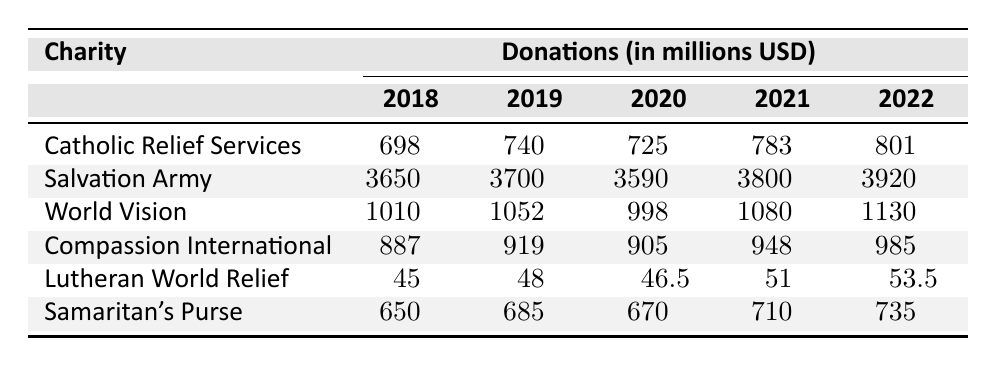What was the highest donation received in 2022? In 2022, the highest donation appears in the row for the Salvation Army with 3920 million USD.
Answer: 3920 million USD Which charity received the least donations in 2020? By looking at the donations for 2020, Lutheran World Relief received the least with 46.5 million USD.
Answer: 46.5 million USD What is the total amount of donations received by Compassion International from 2018 to 2022? Adding the donations from 2018 to 2022 gives us 887 + 919 + 905 + 948 + 985 = 4644 million USD.
Answer: 4644 million USD Did Catholic Relief Services see an increase in donations every year from 2018 to 2022? By comparing the values year by year, we see that donations increased from 698 to 740, then slightly decreased to 725, before increasing again in 2021 and 2022. Hence, there was not a consistent increase every year.
Answer: No How much more did the Salvation Army raise in 2021 compared to the previous year? The difference between the donations in 2021 (3800 million USD) and 2020 (3590 million USD) is calculated as 3800 - 3590 = 210 million USD.
Answer: 210 million USD What is the average donation received by World Vision from 2018 to 2022? To find the average, sum the donations from the indicated years: 1010 + 1052 + 998 + 1080 + 1130 = 5270 million USD. Then divide by 5 (the number of years): 5270 / 5 = 1054 million USD.
Answer: 1054 million USD Which charity showed the highest increase in donations from 2021 to 2022? Comparing the donations from 2021 to 2022 for each charity, Compassion International had an increase of 985 - 948 = 37 million USD, which is the largest increase observed.
Answer: Compassion International Is it true that all charities had donations exceeding 1 billion USD in 2021? Checking the donations for 2021, we find that both Lutheran World Relief (51 million USD) and Catholic Relief Services (783 million USD) did not reach 1 billion USD. Hence, it is false.
Answer: No What was the overall trend of donations for Samaritan's Purse from 2018 to 2022? Analyzing the data shows that Samaritan's Purse had consistent increases in donations every year: 650, 685, 670, 710, and 735 million USD, showing a general upward trend despite a small drop in 2020.
Answer: Generally upward trend with a drop in 2020 